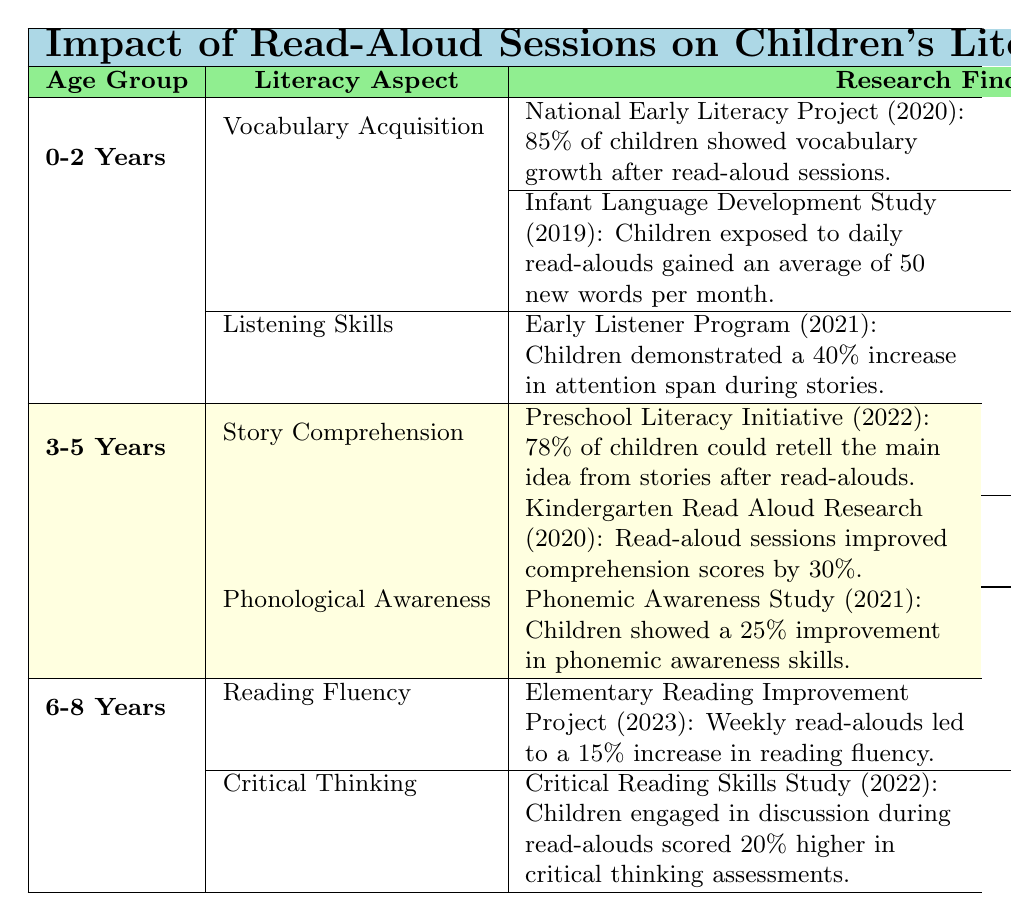What is the finding from the National Early Literacy Project regarding vocabulary growth? The table states that the National Early Literacy Project conducted in 2020 found that 85% of children showed vocabulary growth after read-aloud sessions.
Answer: 85% How many new words did children gain on average per month according to the Infant Language Development Study? According to the data in the table, the Infant Language Development Study from 2019 reported that children exposed to daily read-alouds gained an average of 50 new words per month.
Answer: 50 new words Was there an increase in attention span reported in the Early Listener Program? The table indicates that the Early Listener Program in 2021 reported a 40% increase in attention span during stories, so yes, there was an increase.
Answer: Yes Which age group showed a 25% improvement in phonemic awareness skills? Upon checking the table, it shows that children aged 3-5 years demonstrated a 25% improvement in phonemic awareness skills as indicated by the Phonemic Awareness Study in 2021.
Answer: 3-5 Years How much did reading fluency increase according to the Elementary Reading Improvement Project? The table states that the Elementary Reading Improvement Project in 2023 found that weekly read-alouds led to a 15% increase in reading fluency.
Answer: 15% What is the highest reported increase in critical thinking scores and from which year? The highest reported increase in critical thinking scores was 20%, as found in the Critical Reading Skills Study conducted in 2022.
Answer: 20%, 2022 What percentage of children could retell the main idea from stories in the Preschool Literacy Initiative? The Preschool Literacy Initiative in 2022 states that 78% of children could retell the main idea from stories after read-alouds.
Answer: 78% If we add the percentage increases from the findings, what is the total percentage? Adding up the percentage findings from vocabulary growth (85%), comprehension scores (30%), phonemic awareness (25%), attention span (40%), reading fluency (15%), and critical thinking (20%) gives us a total of 85 + 30 + 25 + 40 + 15 + 20 = 215%.
Answer: 215% 